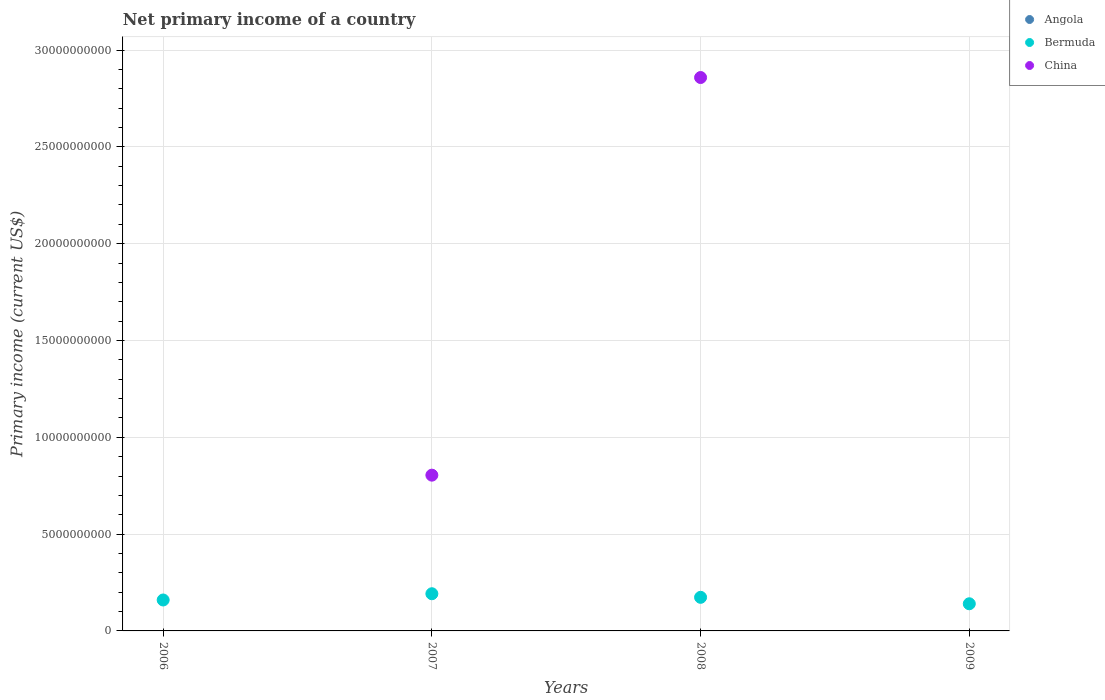How many different coloured dotlines are there?
Keep it short and to the point. 2. Is the number of dotlines equal to the number of legend labels?
Make the answer very short. No. What is the primary income in Angola in 2009?
Provide a short and direct response. 0. Across all years, what is the maximum primary income in China?
Your answer should be compact. 2.86e+1. Across all years, what is the minimum primary income in China?
Ensure brevity in your answer.  0. In which year was the primary income in China maximum?
Give a very brief answer. 2008. What is the total primary income in China in the graph?
Keep it short and to the point. 3.66e+1. What is the difference between the primary income in China in 2007 and that in 2008?
Provide a succinct answer. -2.05e+1. What is the difference between the primary income in China in 2009 and the primary income in Bermuda in 2008?
Keep it short and to the point. -1.74e+09. What is the average primary income in Bermuda per year?
Provide a short and direct response. 1.66e+09. In the year 2008, what is the difference between the primary income in Bermuda and primary income in China?
Provide a short and direct response. -2.68e+1. In how many years, is the primary income in China greater than 20000000000 US$?
Your answer should be very brief. 1. What is the ratio of the primary income in China in 2007 to that in 2008?
Your response must be concise. 0.28. Is the difference between the primary income in Bermuda in 2007 and 2008 greater than the difference between the primary income in China in 2007 and 2008?
Make the answer very short. Yes. What is the difference between the highest and the lowest primary income in China?
Your response must be concise. 2.86e+1. In how many years, is the primary income in Bermuda greater than the average primary income in Bermuda taken over all years?
Offer a very short reply. 2. How many dotlines are there?
Provide a short and direct response. 2. What is the difference between two consecutive major ticks on the Y-axis?
Your answer should be compact. 5.00e+09. Does the graph contain grids?
Make the answer very short. Yes. Where does the legend appear in the graph?
Provide a succinct answer. Top right. How many legend labels are there?
Offer a terse response. 3. What is the title of the graph?
Offer a very short reply. Net primary income of a country. Does "Suriname" appear as one of the legend labels in the graph?
Provide a short and direct response. No. What is the label or title of the Y-axis?
Make the answer very short. Primary income (current US$). What is the Primary income (current US$) of Angola in 2006?
Offer a terse response. 0. What is the Primary income (current US$) in Bermuda in 2006?
Provide a short and direct response. 1.60e+09. What is the Primary income (current US$) of Angola in 2007?
Make the answer very short. 0. What is the Primary income (current US$) in Bermuda in 2007?
Your response must be concise. 1.92e+09. What is the Primary income (current US$) of China in 2007?
Offer a very short reply. 8.04e+09. What is the Primary income (current US$) in Bermuda in 2008?
Give a very brief answer. 1.74e+09. What is the Primary income (current US$) in China in 2008?
Your answer should be compact. 2.86e+1. What is the Primary income (current US$) of Bermuda in 2009?
Make the answer very short. 1.40e+09. Across all years, what is the maximum Primary income (current US$) of Bermuda?
Provide a succinct answer. 1.92e+09. Across all years, what is the maximum Primary income (current US$) in China?
Ensure brevity in your answer.  2.86e+1. Across all years, what is the minimum Primary income (current US$) in Bermuda?
Ensure brevity in your answer.  1.40e+09. What is the total Primary income (current US$) of Bermuda in the graph?
Ensure brevity in your answer.  6.66e+09. What is the total Primary income (current US$) in China in the graph?
Provide a succinct answer. 3.66e+1. What is the difference between the Primary income (current US$) in Bermuda in 2006 and that in 2007?
Your response must be concise. -3.23e+08. What is the difference between the Primary income (current US$) of Bermuda in 2006 and that in 2008?
Make the answer very short. -1.38e+08. What is the difference between the Primary income (current US$) of Bermuda in 2006 and that in 2009?
Give a very brief answer. 1.95e+08. What is the difference between the Primary income (current US$) in Bermuda in 2007 and that in 2008?
Ensure brevity in your answer.  1.85e+08. What is the difference between the Primary income (current US$) of China in 2007 and that in 2008?
Your response must be concise. -2.05e+1. What is the difference between the Primary income (current US$) in Bermuda in 2007 and that in 2009?
Offer a very short reply. 5.18e+08. What is the difference between the Primary income (current US$) of Bermuda in 2008 and that in 2009?
Provide a short and direct response. 3.33e+08. What is the difference between the Primary income (current US$) in Bermuda in 2006 and the Primary income (current US$) in China in 2007?
Make the answer very short. -6.45e+09. What is the difference between the Primary income (current US$) in Bermuda in 2006 and the Primary income (current US$) in China in 2008?
Your answer should be compact. -2.70e+1. What is the difference between the Primary income (current US$) of Bermuda in 2007 and the Primary income (current US$) of China in 2008?
Provide a short and direct response. -2.67e+1. What is the average Primary income (current US$) in Bermuda per year?
Offer a very short reply. 1.66e+09. What is the average Primary income (current US$) of China per year?
Your answer should be very brief. 9.16e+09. In the year 2007, what is the difference between the Primary income (current US$) of Bermuda and Primary income (current US$) of China?
Your answer should be very brief. -6.12e+09. In the year 2008, what is the difference between the Primary income (current US$) of Bermuda and Primary income (current US$) of China?
Give a very brief answer. -2.68e+1. What is the ratio of the Primary income (current US$) of Bermuda in 2006 to that in 2007?
Provide a short and direct response. 0.83. What is the ratio of the Primary income (current US$) of Bermuda in 2006 to that in 2008?
Your response must be concise. 0.92. What is the ratio of the Primary income (current US$) in Bermuda in 2006 to that in 2009?
Your response must be concise. 1.14. What is the ratio of the Primary income (current US$) in Bermuda in 2007 to that in 2008?
Make the answer very short. 1.11. What is the ratio of the Primary income (current US$) in China in 2007 to that in 2008?
Your answer should be compact. 0.28. What is the ratio of the Primary income (current US$) in Bermuda in 2007 to that in 2009?
Your answer should be very brief. 1.37. What is the ratio of the Primary income (current US$) of Bermuda in 2008 to that in 2009?
Keep it short and to the point. 1.24. What is the difference between the highest and the second highest Primary income (current US$) of Bermuda?
Give a very brief answer. 1.85e+08. What is the difference between the highest and the lowest Primary income (current US$) in Bermuda?
Give a very brief answer. 5.18e+08. What is the difference between the highest and the lowest Primary income (current US$) of China?
Offer a terse response. 2.86e+1. 